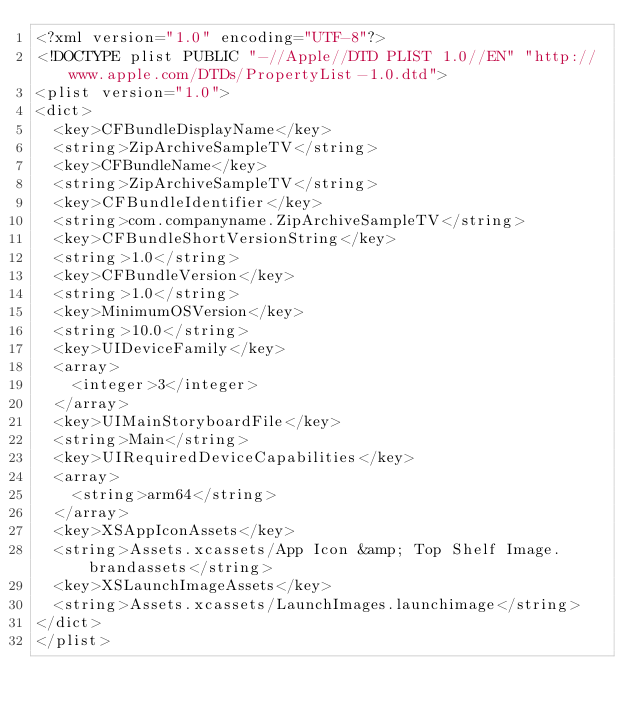Convert code to text. <code><loc_0><loc_0><loc_500><loc_500><_XML_><?xml version="1.0" encoding="UTF-8"?>
<!DOCTYPE plist PUBLIC "-//Apple//DTD PLIST 1.0//EN" "http://www.apple.com/DTDs/PropertyList-1.0.dtd">
<plist version="1.0">
<dict>
	<key>CFBundleDisplayName</key>
	<string>ZipArchiveSampleTV</string>
	<key>CFBundleName</key>
	<string>ZipArchiveSampleTV</string>
	<key>CFBundleIdentifier</key>
	<string>com.companyname.ZipArchiveSampleTV</string>
	<key>CFBundleShortVersionString</key>
	<string>1.0</string>
	<key>CFBundleVersion</key>
	<string>1.0</string>
	<key>MinimumOSVersion</key>
	<string>10.0</string>
	<key>UIDeviceFamily</key>
	<array>
		<integer>3</integer>
	</array>
	<key>UIMainStoryboardFile</key>
	<string>Main</string>
	<key>UIRequiredDeviceCapabilities</key>
	<array>
		<string>arm64</string>
	</array>
	<key>XSAppIconAssets</key>
	<string>Assets.xcassets/App Icon &amp; Top Shelf Image.brandassets</string>
	<key>XSLaunchImageAssets</key>
	<string>Assets.xcassets/LaunchImages.launchimage</string>
</dict>
</plist>
</code> 